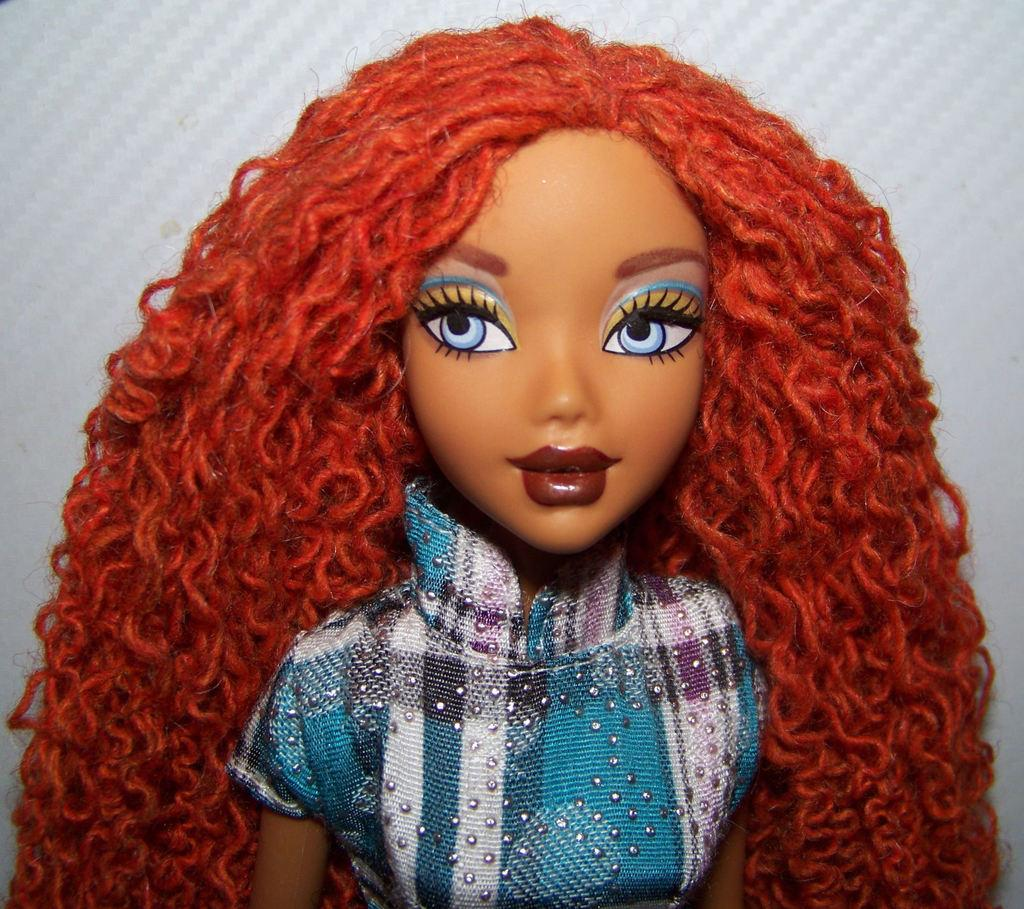What is the main subject of the image? There is a doll in the image. What is the doll wearing? The doll is wearing a blue and white dress. What color is the background of the image? The background of the image is white. What type of sign can be seen in the background of the image? There is no sign present in the background of the image; it is a white background with no additional elements. 